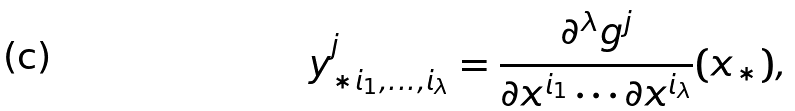<formula> <loc_0><loc_0><loc_500><loc_500>y _ { * i _ { 1 } , \dots , i _ { \lambda } } ^ { j } = \frac { \partial ^ { \lambda } g ^ { j } } { \partial x ^ { i _ { 1 } } \cdots \partial x ^ { i _ { \lambda } } } ( x _ { * } ) ,</formula> 